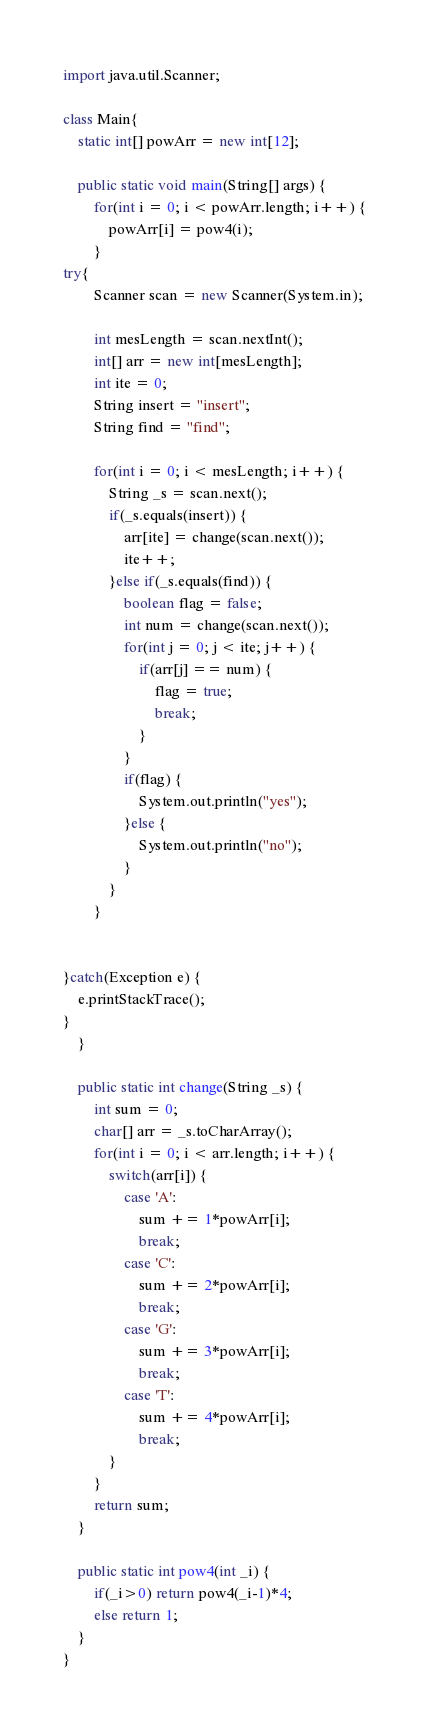<code> <loc_0><loc_0><loc_500><loc_500><_Java_>import java.util.Scanner;

class Main{
	static int[] powArr = new int[12];

	public static void main(String[] args) {
		for(int i = 0; i < powArr.length; i++) {
			powArr[i] = pow4(i);
		}
try{
		Scanner scan = new Scanner(System.in);

		int mesLength = scan.nextInt();
		int[] arr = new int[mesLength];
		int ite = 0;
		String insert = "insert";
		String find = "find";

		for(int i = 0; i < mesLength; i++) {
			String _s = scan.next();
			if(_s.equals(insert)) {
				arr[ite] = change(scan.next());
				ite++;
			}else if(_s.equals(find)) {
				boolean flag = false;
				int num = change(scan.next());
				for(int j = 0; j < ite; j++) {
					if(arr[j] == num) {
						flag = true;
						break;
					}
				}
				if(flag) {
					System.out.println("yes");
				}else {
					System.out.println("no");
				}
			}
		}
		

}catch(Exception e) {
	e.printStackTrace();
}
	}

	public static int change(String _s) {
		int sum = 0;
		char[] arr = _s.toCharArray();
		for(int i = 0; i < arr.length; i++) {
			switch(arr[i]) {
				case 'A':
					sum += 1*powArr[i];
					break;
				case 'C':
					sum += 2*powArr[i];
					break;
				case 'G':
					sum += 3*powArr[i];
					break;
				case 'T':
					sum += 4*powArr[i];
					break;
			}
		}
		return sum;
	}

	public static int pow4(int _i) {
		if(_i>0) return pow4(_i-1)*4;
		else return 1;
	}
}</code> 